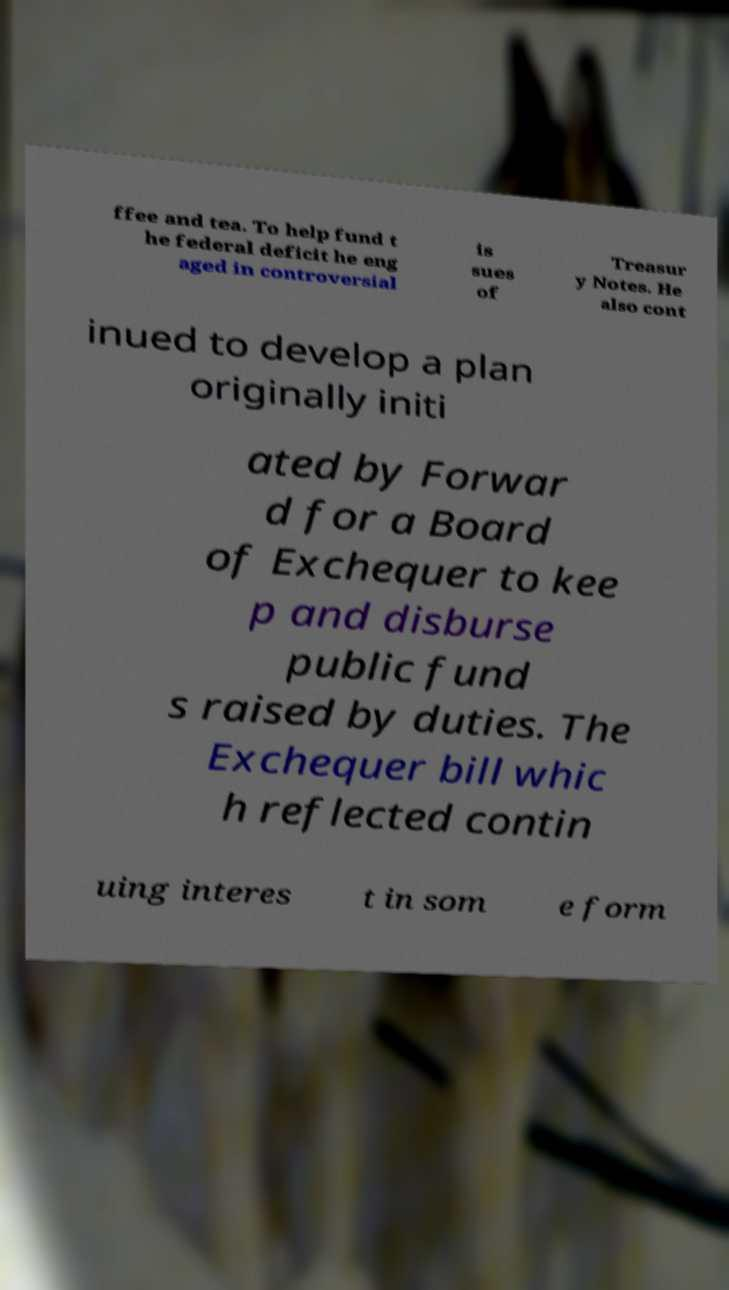Can you read and provide the text displayed in the image?This photo seems to have some interesting text. Can you extract and type it out for me? ffee and tea. To help fund t he federal deficit he eng aged in controversial is sues of Treasur y Notes. He also cont inued to develop a plan originally initi ated by Forwar d for a Board of Exchequer to kee p and disburse public fund s raised by duties. The Exchequer bill whic h reflected contin uing interes t in som e form 